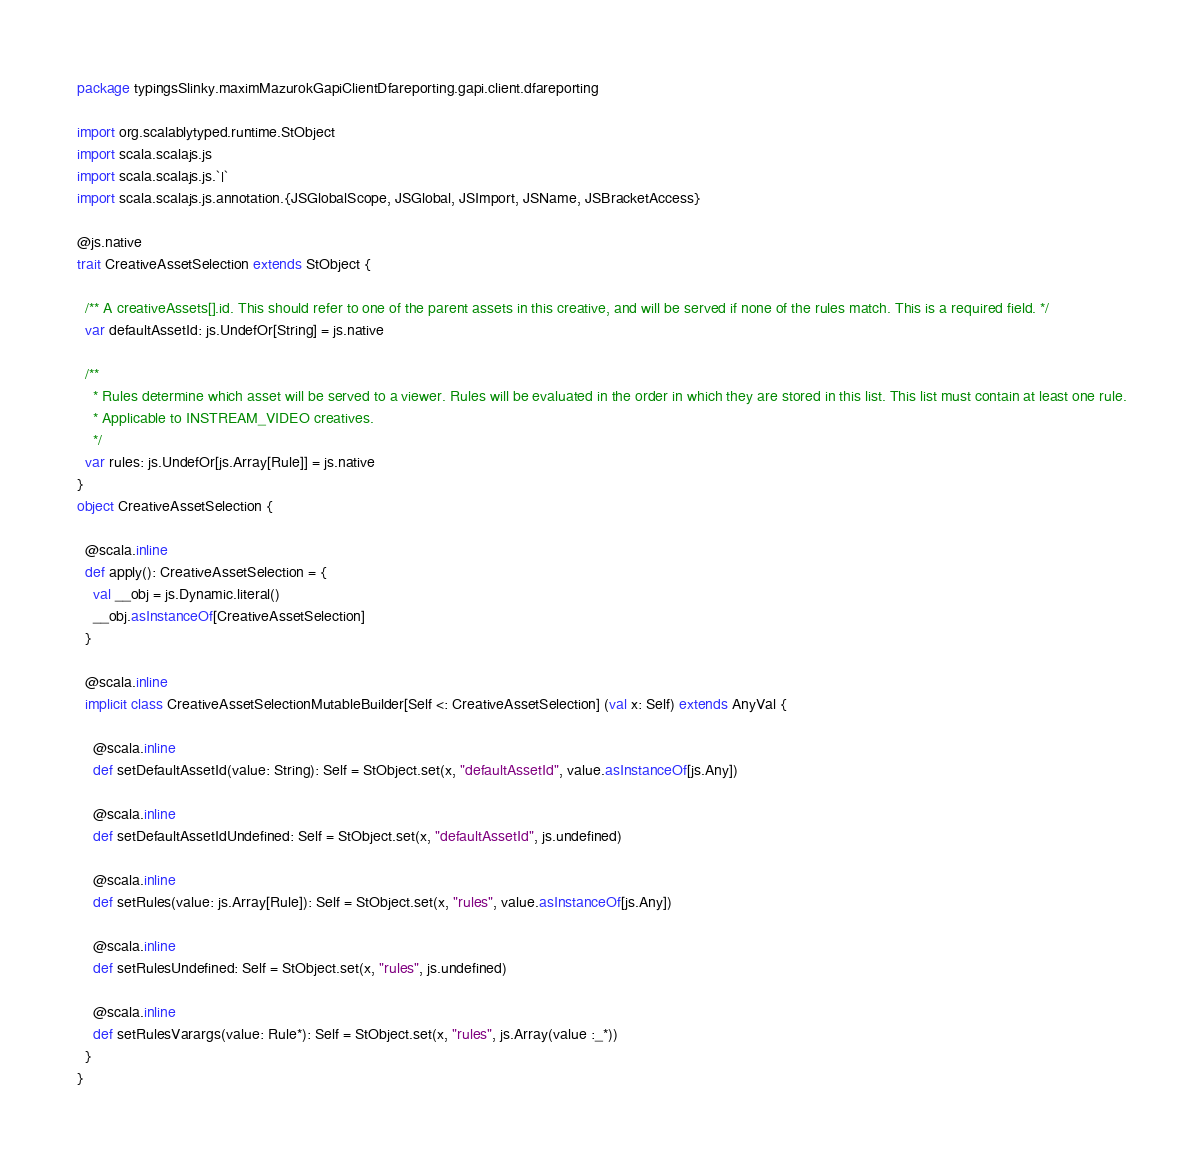Convert code to text. <code><loc_0><loc_0><loc_500><loc_500><_Scala_>package typingsSlinky.maximMazurokGapiClientDfareporting.gapi.client.dfareporting

import org.scalablytyped.runtime.StObject
import scala.scalajs.js
import scala.scalajs.js.`|`
import scala.scalajs.js.annotation.{JSGlobalScope, JSGlobal, JSImport, JSName, JSBracketAccess}

@js.native
trait CreativeAssetSelection extends StObject {
  
  /** A creativeAssets[].id. This should refer to one of the parent assets in this creative, and will be served if none of the rules match. This is a required field. */
  var defaultAssetId: js.UndefOr[String] = js.native
  
  /**
    * Rules determine which asset will be served to a viewer. Rules will be evaluated in the order in which they are stored in this list. This list must contain at least one rule.
    * Applicable to INSTREAM_VIDEO creatives.
    */
  var rules: js.UndefOr[js.Array[Rule]] = js.native
}
object CreativeAssetSelection {
  
  @scala.inline
  def apply(): CreativeAssetSelection = {
    val __obj = js.Dynamic.literal()
    __obj.asInstanceOf[CreativeAssetSelection]
  }
  
  @scala.inline
  implicit class CreativeAssetSelectionMutableBuilder[Self <: CreativeAssetSelection] (val x: Self) extends AnyVal {
    
    @scala.inline
    def setDefaultAssetId(value: String): Self = StObject.set(x, "defaultAssetId", value.asInstanceOf[js.Any])
    
    @scala.inline
    def setDefaultAssetIdUndefined: Self = StObject.set(x, "defaultAssetId", js.undefined)
    
    @scala.inline
    def setRules(value: js.Array[Rule]): Self = StObject.set(x, "rules", value.asInstanceOf[js.Any])
    
    @scala.inline
    def setRulesUndefined: Self = StObject.set(x, "rules", js.undefined)
    
    @scala.inline
    def setRulesVarargs(value: Rule*): Self = StObject.set(x, "rules", js.Array(value :_*))
  }
}
</code> 